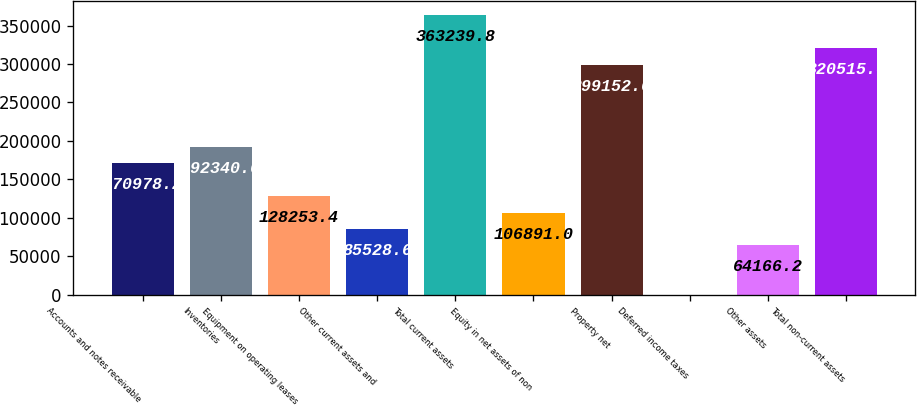<chart> <loc_0><loc_0><loc_500><loc_500><bar_chart><fcel>Accounts and notes receivable<fcel>Inventories<fcel>Equipment on operating leases<fcel>Other current assets and<fcel>Total current assets<fcel>Equity in net assets of non<fcel>Property net<fcel>Deferred income taxes<fcel>Other assets<fcel>Total non-current assets<nl><fcel>170978<fcel>192341<fcel>128253<fcel>85528.6<fcel>363240<fcel>106891<fcel>299153<fcel>79<fcel>64166.2<fcel>320515<nl></chart> 